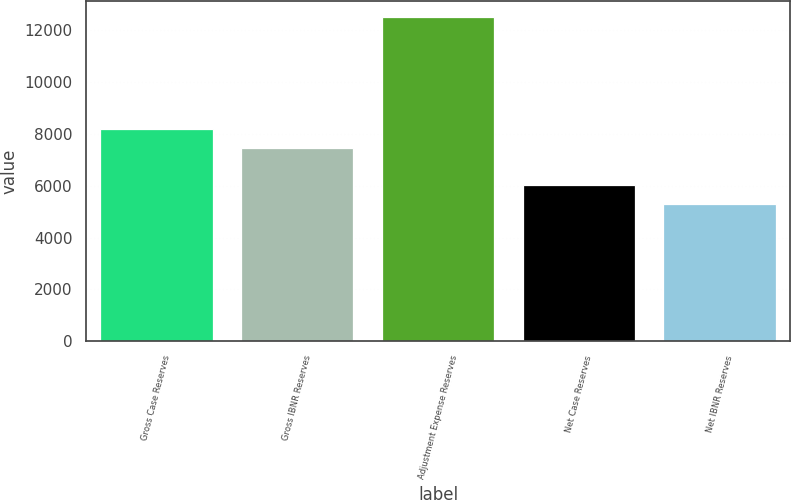Convert chart to OTSL. <chart><loc_0><loc_0><loc_500><loc_500><bar_chart><fcel>Gross Case Reserves<fcel>Gross IBNR Reserves<fcel>Adjustment Expense Reserves<fcel>Net Case Reserves<fcel>Net IBNR Reserves<nl><fcel>8184<fcel>7461<fcel>12522<fcel>6015<fcel>5292<nl></chart> 